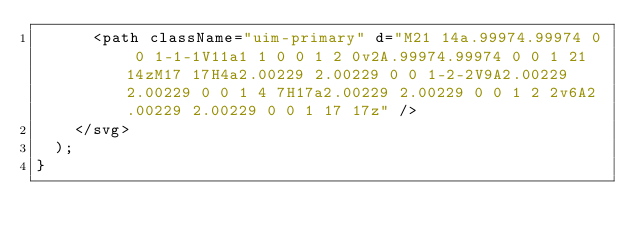Convert code to text. <code><loc_0><loc_0><loc_500><loc_500><_JavaScript_>      <path className="uim-primary" d="M21 14a.99974.99974 0 0 1-1-1V11a1 1 0 0 1 2 0v2A.99974.99974 0 0 1 21 14zM17 17H4a2.00229 2.00229 0 0 1-2-2V9A2.00229 2.00229 0 0 1 4 7H17a2.00229 2.00229 0 0 1 2 2v6A2.00229 2.00229 0 0 1 17 17z" />
    </svg>
  );
}
</code> 